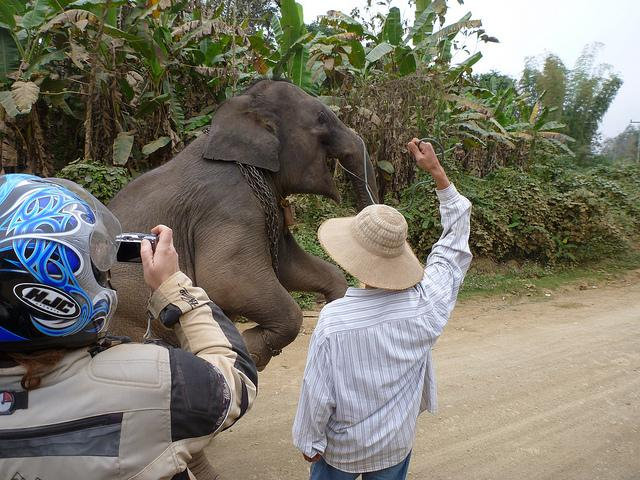Why does the man use a rope? Please explain your reasoning. control. The rope is used by the man to control the elephant so it doesn't stray away 